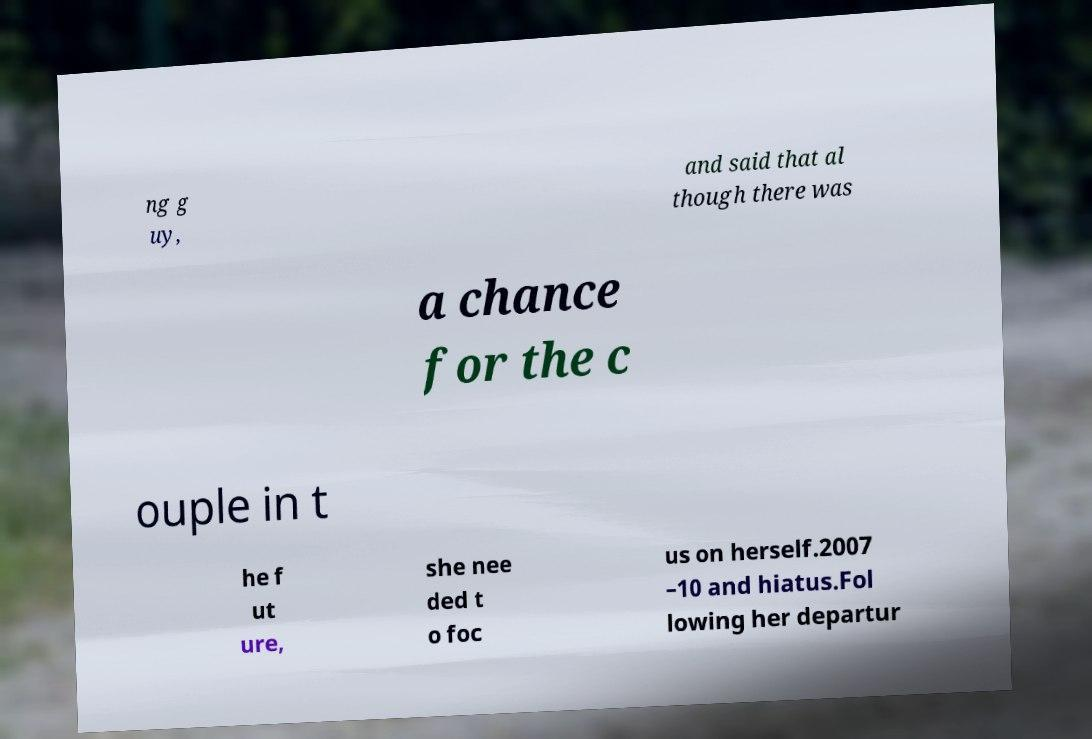Please read and relay the text visible in this image. What does it say? ng g uy, and said that al though there was a chance for the c ouple in t he f ut ure, she nee ded t o foc us on herself.2007 –10 and hiatus.Fol lowing her departur 